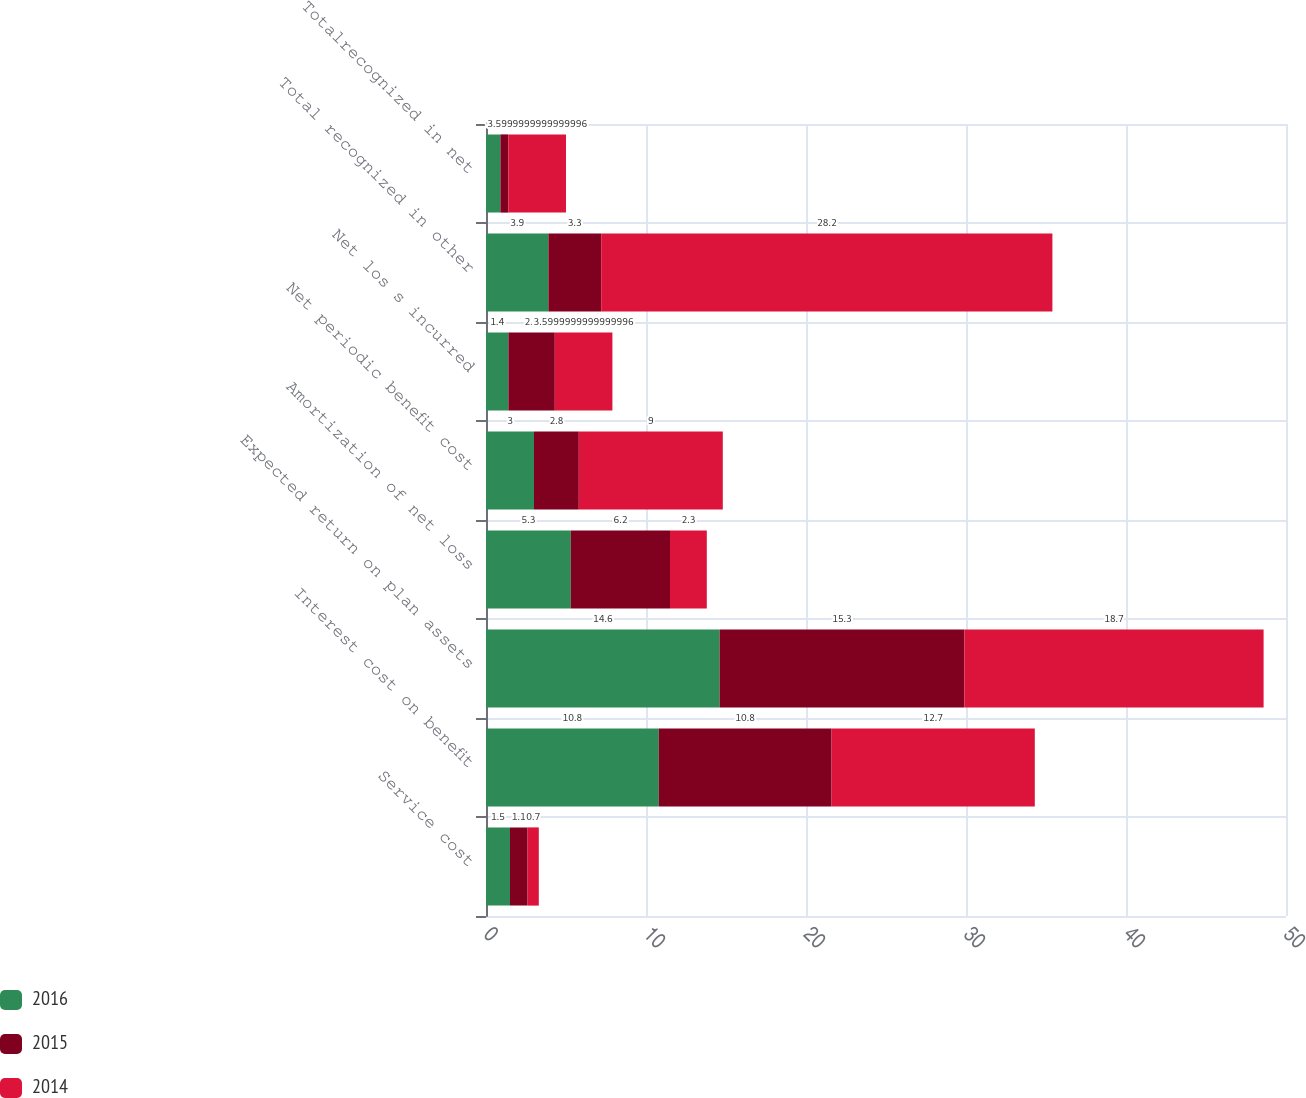Convert chart to OTSL. <chart><loc_0><loc_0><loc_500><loc_500><stacked_bar_chart><ecel><fcel>Service cost<fcel>Interest cost on benefit<fcel>Expected return on plan assets<fcel>Amortization of net loss<fcel>Net periodic benefit cost<fcel>Net los s incurred<fcel>Total recognized in other<fcel>Totalrecognized in net<nl><fcel>2016<fcel>1.5<fcel>10.8<fcel>14.6<fcel>5.3<fcel>3<fcel>1.4<fcel>3.9<fcel>0.9<nl><fcel>2015<fcel>1.1<fcel>10.8<fcel>15.3<fcel>6.2<fcel>2.8<fcel>2.9<fcel>3.3<fcel>0.5<nl><fcel>2014<fcel>0.7<fcel>12.7<fcel>18.7<fcel>2.3<fcel>9<fcel>3.6<fcel>28.2<fcel>3.6<nl></chart> 